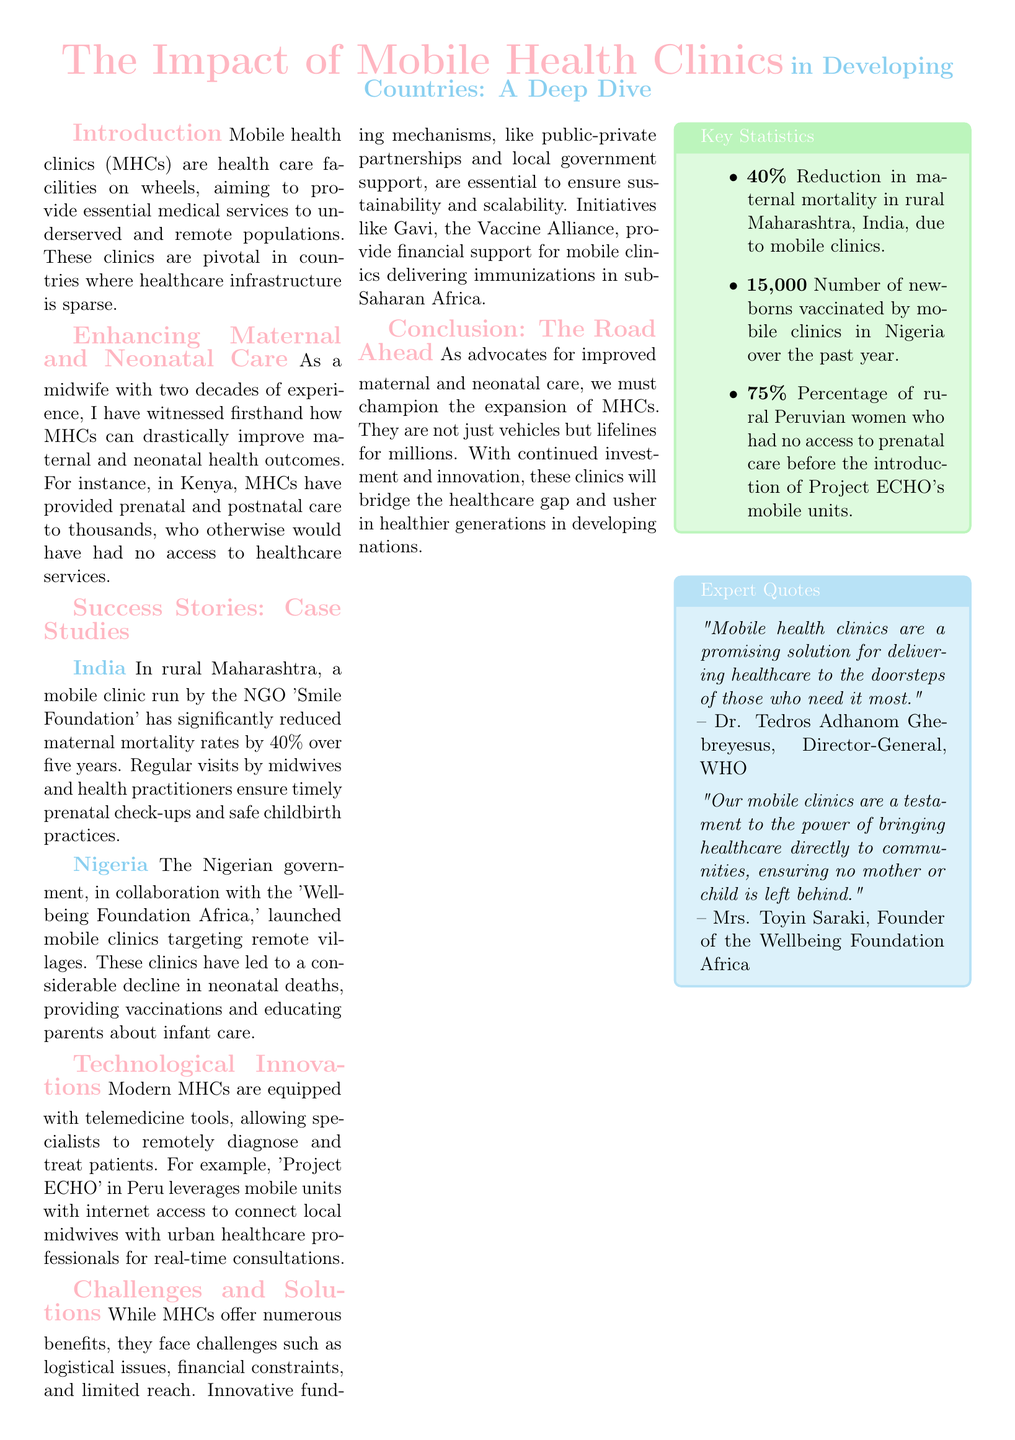what are mobile health clinics? Mobile health clinics (MHCs) are health care facilities on wheels, providing essential medical services to underserved populations.
Answer: health care facilities on wheels how much did maternal mortality rates reduce in rural Maharashtra, India? The document states that mobile clinics in rural Maharashtra reduced maternal mortality rates by 40%.
Answer: 40% how many newborns were vaccinated by mobile clinics in Nigeria over the past year? According to the document, mobile clinics in Nigeria vaccinated 15,000 newborns in the past year.
Answer: 15,000 what innovative project connects local midwives with urban healthcare professionals in Peru? The document mentions "Project ECHO" as the innovative project that connects local midwives with urban healthcare professionals.
Answer: Project ECHO who is the director-general of WHO mentioned in the expert quotes? The document cites Dr. Tedros Adhanom Ghebreyesus as the director-general of WHO.
Answer: Dr. Tedros Adhanom Ghebreyesus what color is used for the section title in the document? The section titles in the document are highlighted with the color midwifePink.
Answer: midwifePink what is the main focus of the conclusion section? The conclusion emphasizes the expansion of mobile health clinics as vital for maternal and neonatal care.
Answer: expansion of mobile health clinics how many percentage of rural Peruvian women had no access to prenatal care before mobile units were introduced? The document states that 75% of rural Peruvian women had no access to prenatal care before the introduction of mobile units.
Answer: 75% what organization collaborated with the Nigerian government for mobile clinics? The document mentions the "Wellbeing Foundation Africa" collaborated with the Nigerian government.
Answer: Wellbeing Foundation Africa 